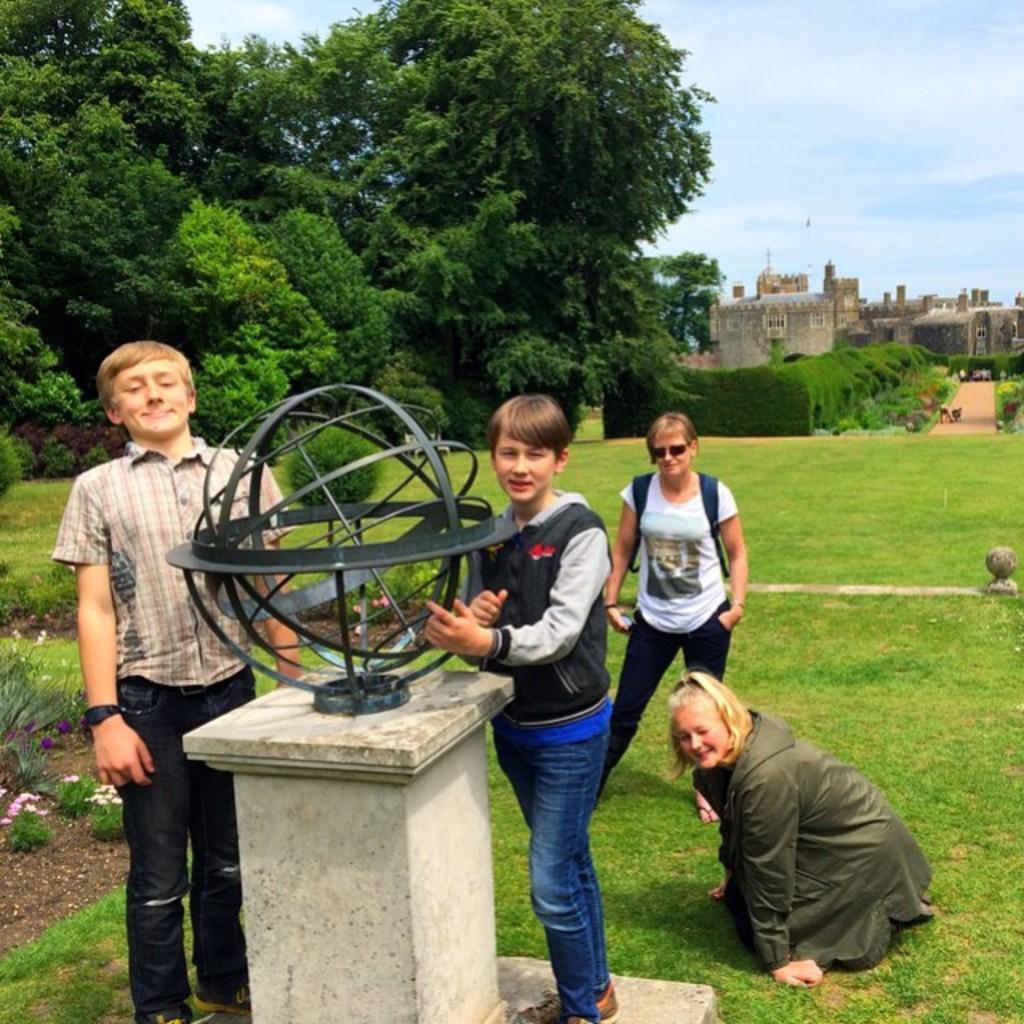Could you give a brief overview of what you see in this image? In this picture I can see four persons, there is a metal globe, there are plants, flowers, trees, there is a fort, and in the background there is sky. 